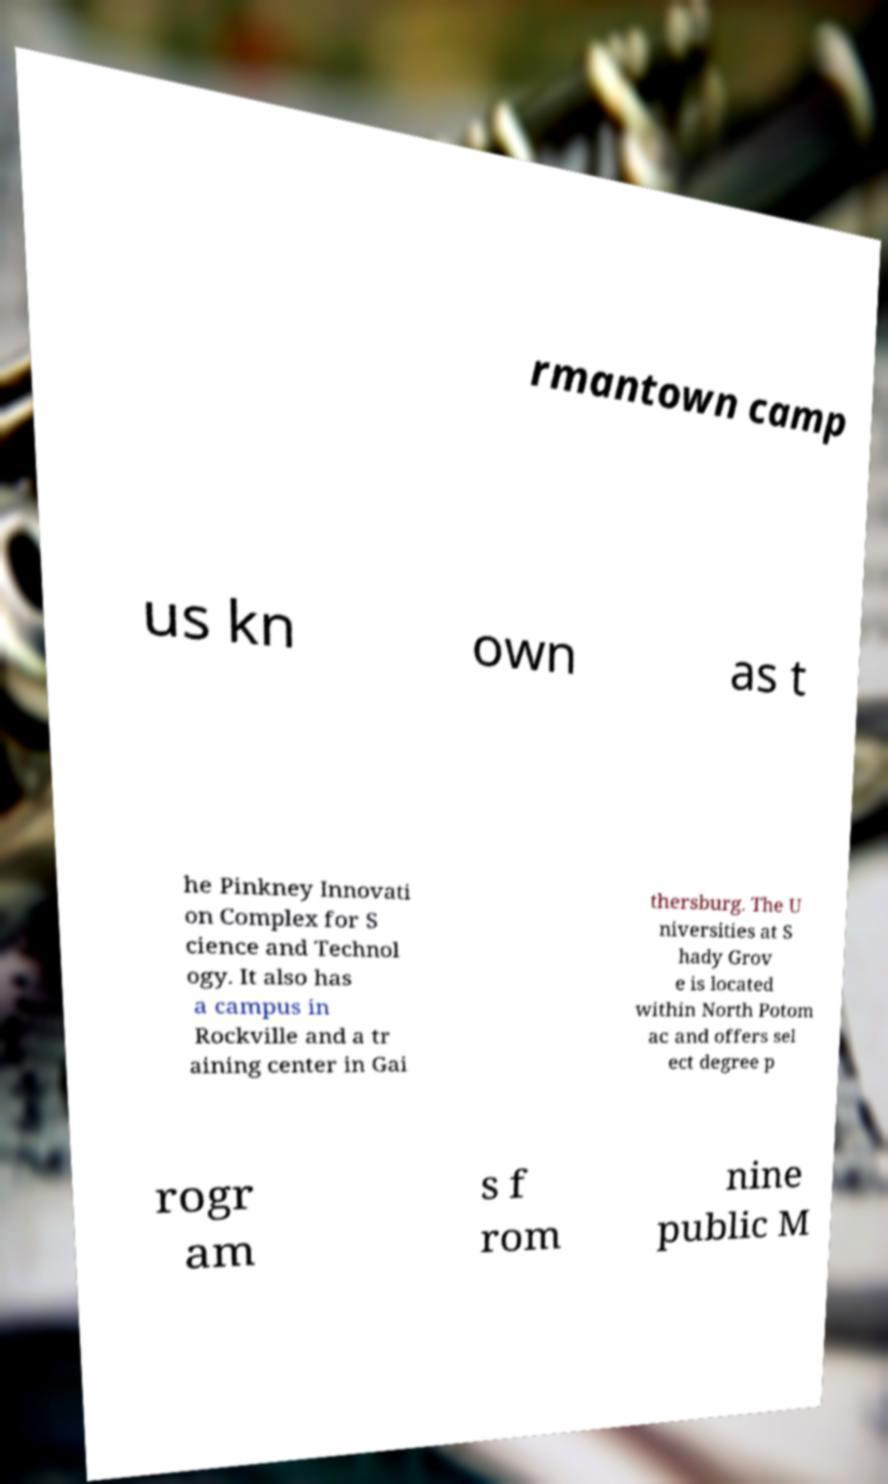I need the written content from this picture converted into text. Can you do that? rmantown camp us kn own as t he Pinkney Innovati on Complex for S cience and Technol ogy. It also has a campus in Rockville and a tr aining center in Gai thersburg. The U niversities at S hady Grov e is located within North Potom ac and offers sel ect degree p rogr am s f rom nine public M 